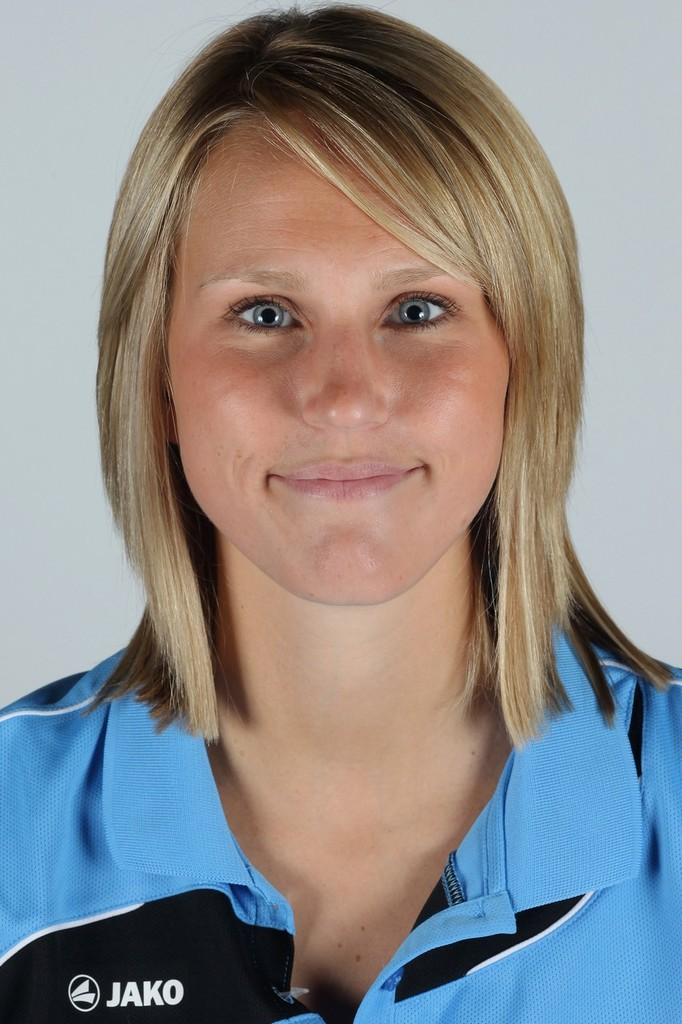Provide a one-sentence caption for the provided image. A girl wearing a blue shirt with the word Jako on it is smiling. 